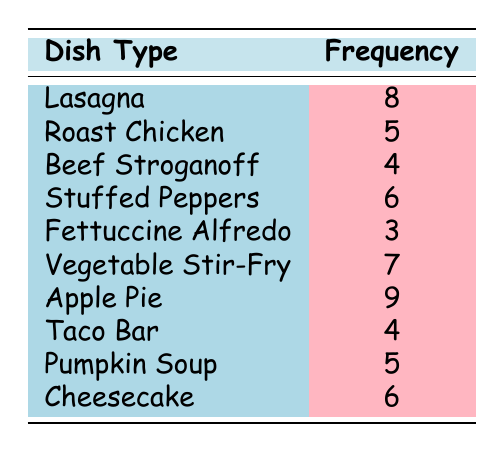What is the most frequently served dish? By inspecting the frequency column in the table, I can identify the dish with the highest frequency value, which is 9. The dish associated with this frequency is "Apple Pie."
Answer: Apple Pie How many times was "Fettuccine Alfredo" served? The table explicitly shows that "Fettuccine Alfredo" has a frequency of 3. Thus, it was served 3 times.
Answer: 3 Which dishes were served more than 5 times? I can look at the frequency values and filter those greater than 5. The dishes with their respective frequencies are: "Lasagna" (8), "Vegetable Stir-Fry" (7), and "Apple Pie" (9).
Answer: Lasagna, Vegetable Stir-Fry, Apple Pie What is the total frequency of all dishes served? To find the total frequency, I will add all the frequency values in the table: 8 + 5 + 4 + 6 + 3 + 7 + 9 + 4 + 5 + 6 = 57.
Answer: 57 Is "Beef Stroganoff" served more frequently than "Pumpkin Soup"? According to the frequency column, "Beef Stroganoff" has a frequency of 4, and "Pumpkin Soup" has a frequency of 5. Since 4 is less than 5, "Beef Stroganoff" is not served more frequently than "Pumpkin Soup."
Answer: No What is the average frequency of all dishes? To find the average frequency, I will divide the total frequency (57) by the number of dish types (10). Thus, the average is 57/10 = 5.7.
Answer: 5.7 How many dishes were served with a frequency of 4 or less? I will review the frequency values: "Beef Stroganoff" (4), "Taco Bar" (4), and "Fettuccine Alfredo" (3). That gives me a total of 3 dishes that were served 4 times or fewer.
Answer: 3 What is the difference between the highest and lowest frequency? The highest frequency is 9 ("Apple Pie") and the lowest is 3 ("Fettuccine Alfredo"). The difference is 9 - 3 = 6.
Answer: 6 Which dishes have the same frequency? Looking at the frequency column, "Roast Chicken" (5) and "Pumpkin Soup" (5) have the same frequency.
Answer: Roast Chicken, Pumpkin Soup 